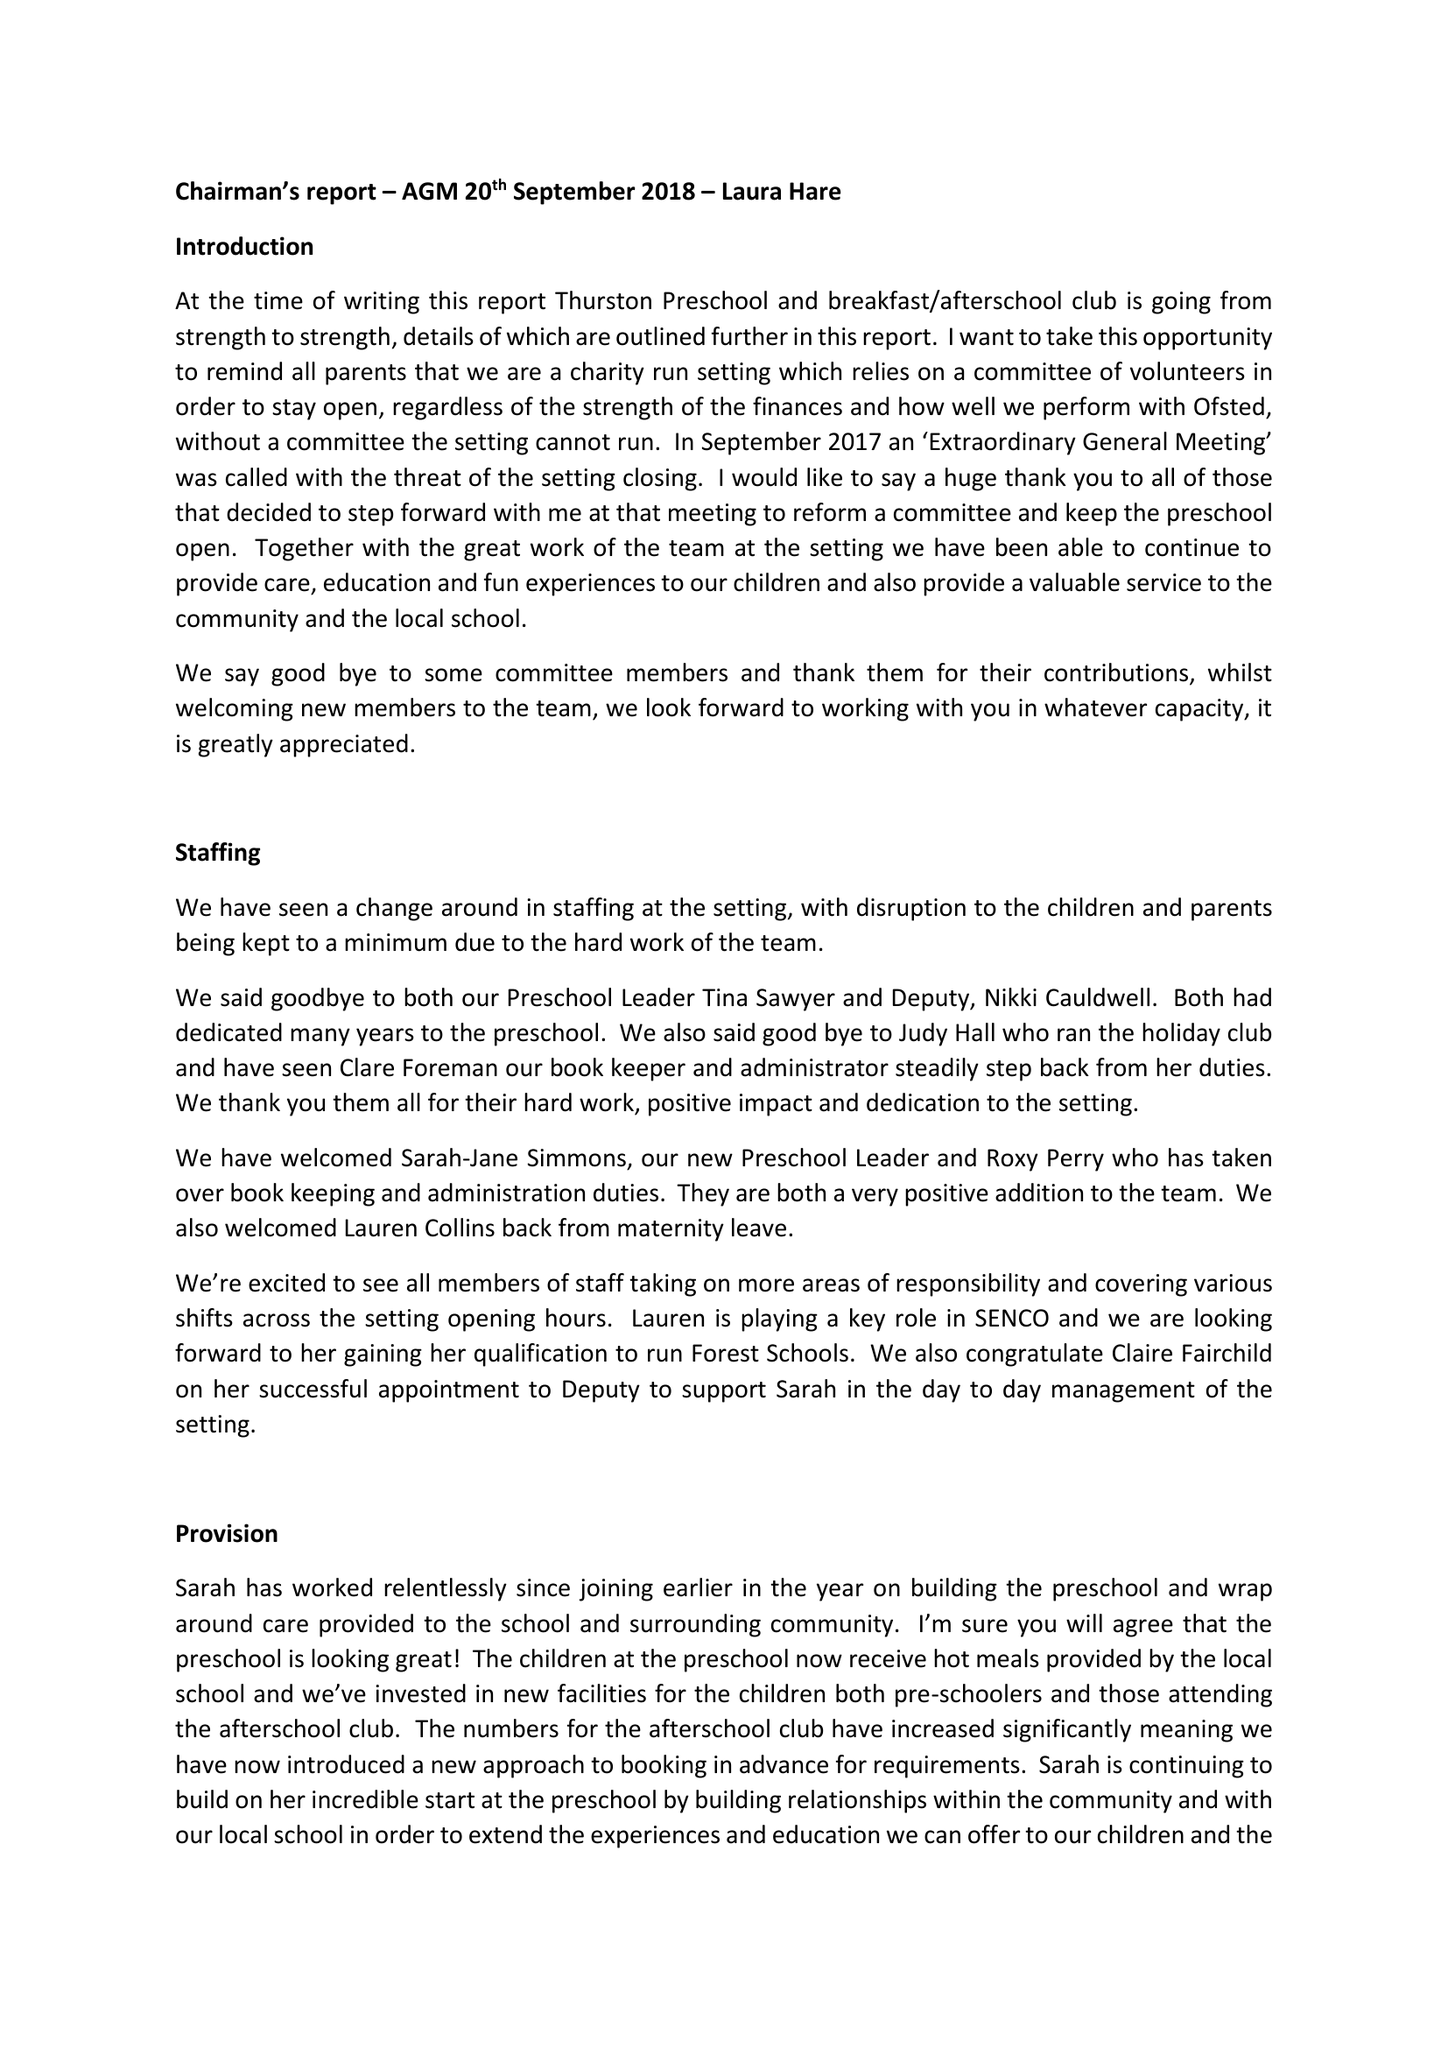What is the value for the address__postcode?
Answer the question using a single word or phrase. IP31 3RU 